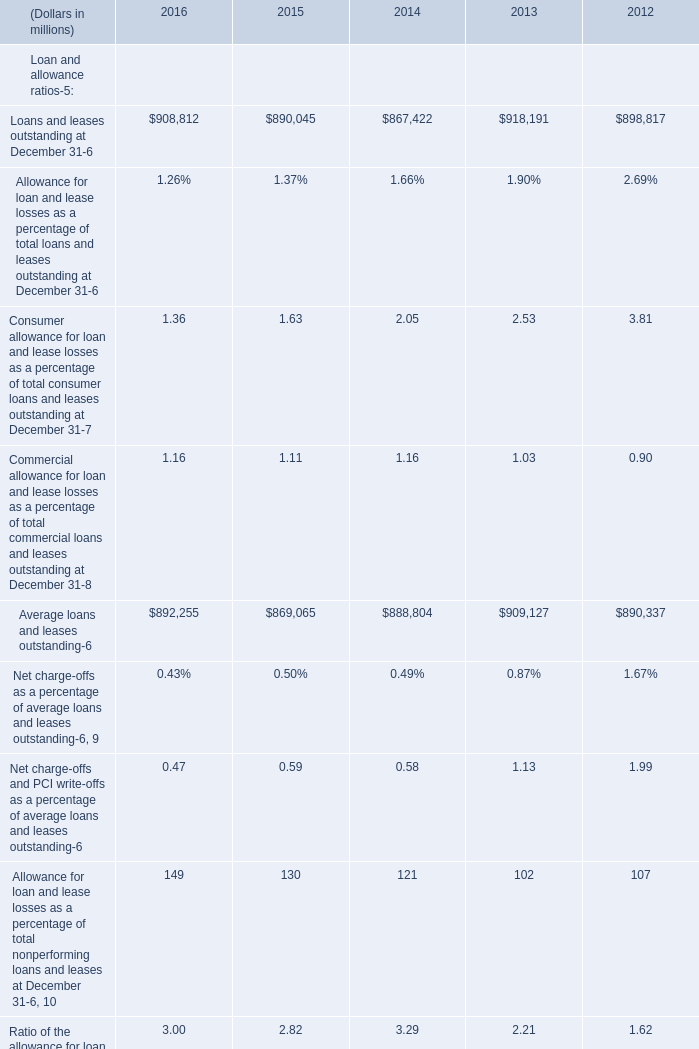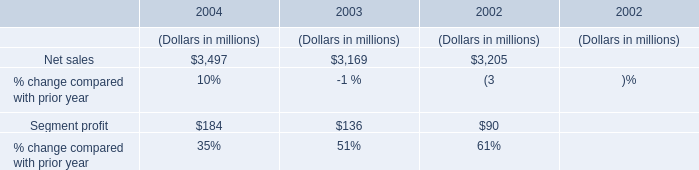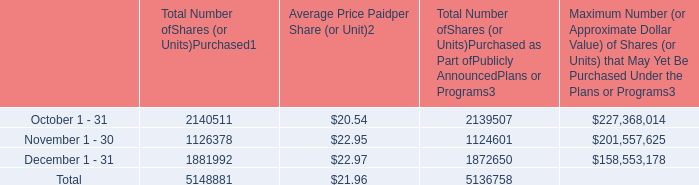What's the growth rate of Loans and leases outstanding at December 31 in 2016? 
Computations: ((908812 - 890045) / 890045)
Answer: 0.02109. 